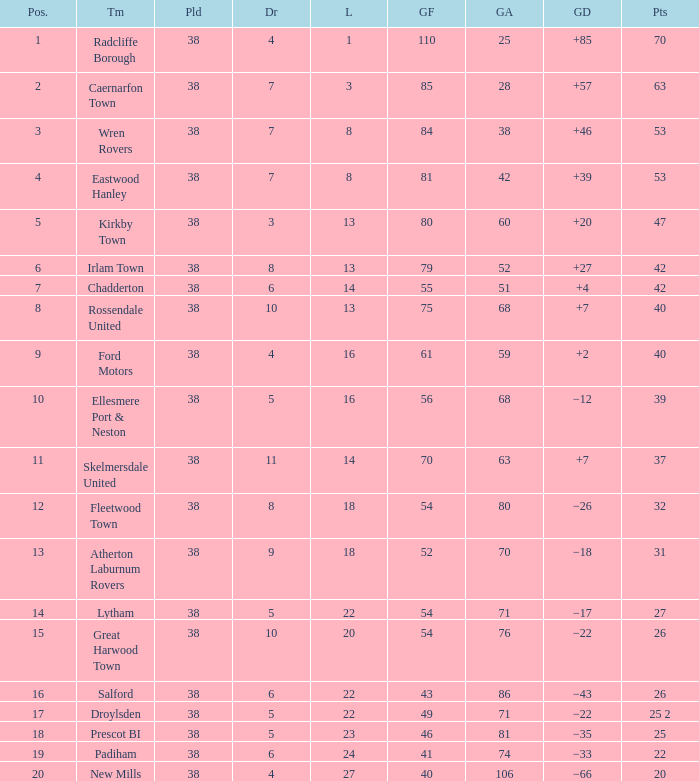Which Lost has a Position larger than 5, and Points 1 of 37, and less than 63 Goals Against? None. Could you parse the entire table? {'header': ['Pos.', 'Tm', 'Pld', 'Dr', 'L', 'GF', 'GA', 'GD', 'Pts'], 'rows': [['1', 'Radcliffe Borough', '38', '4', '1', '110', '25', '+85', '70'], ['2', 'Caernarfon Town', '38', '7', '3', '85', '28', '+57', '63'], ['3', 'Wren Rovers', '38', '7', '8', '84', '38', '+46', '53'], ['4', 'Eastwood Hanley', '38', '7', '8', '81', '42', '+39', '53'], ['5', 'Kirkby Town', '38', '3', '13', '80', '60', '+20', '47'], ['6', 'Irlam Town', '38', '8', '13', '79', '52', '+27', '42'], ['7', 'Chadderton', '38', '6', '14', '55', '51', '+4', '42'], ['8', 'Rossendale United', '38', '10', '13', '75', '68', '+7', '40'], ['9', 'Ford Motors', '38', '4', '16', '61', '59', '+2', '40'], ['10', 'Ellesmere Port & Neston', '38', '5', '16', '56', '68', '−12', '39'], ['11', 'Skelmersdale United', '38', '11', '14', '70', '63', '+7', '37'], ['12', 'Fleetwood Town', '38', '8', '18', '54', '80', '−26', '32'], ['13', 'Atherton Laburnum Rovers', '38', '9', '18', '52', '70', '−18', '31'], ['14', 'Lytham', '38', '5', '22', '54', '71', '−17', '27'], ['15', 'Great Harwood Town', '38', '10', '20', '54', '76', '−22', '26'], ['16', 'Salford', '38', '6', '22', '43', '86', '−43', '26'], ['17', 'Droylsden', '38', '5', '22', '49', '71', '−22', '25 2'], ['18', 'Prescot BI', '38', '5', '23', '46', '81', '−35', '25'], ['19', 'Padiham', '38', '6', '24', '41', '74', '−33', '22'], ['20', 'New Mills', '38', '4', '27', '40', '106', '−66', '20']]} 